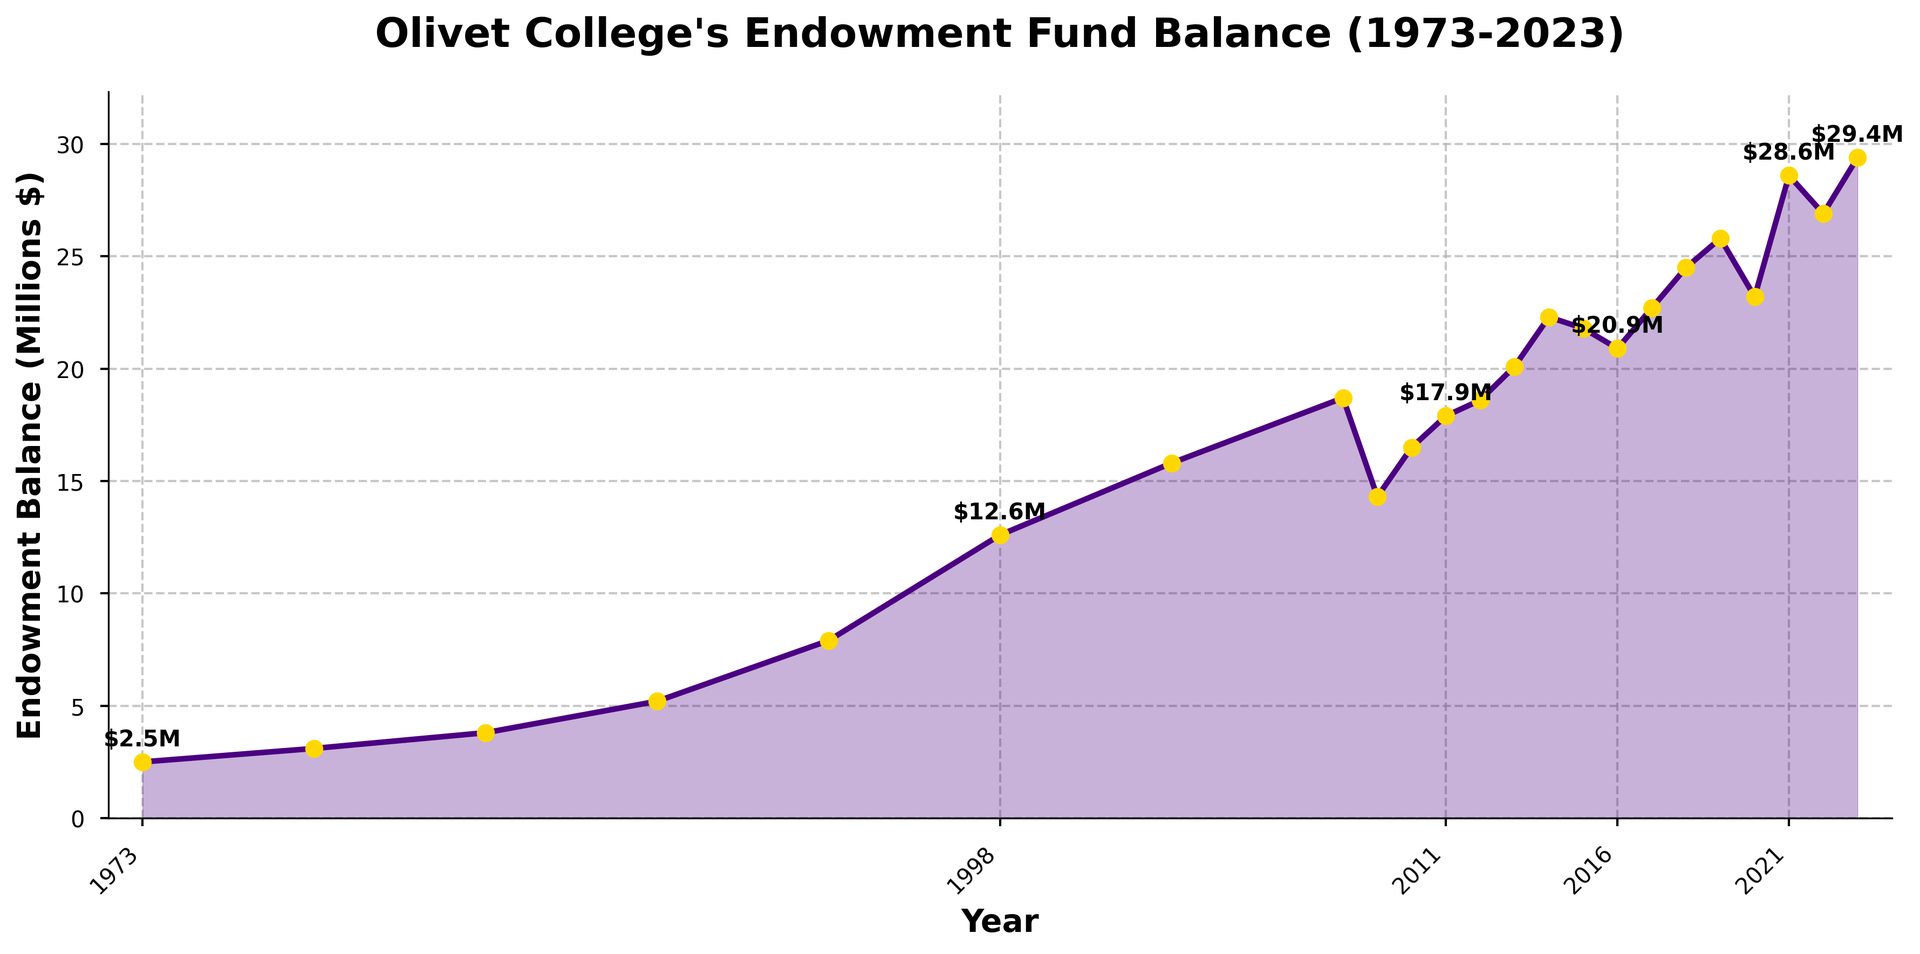What year saw the largest drop in the endowment balance? Look for the year-by-year difference in the endowment balance and find the largest negative change. The balance dropped significantly from 2008 to 2009.
Answer: 2009 What was the endowment balance in 1993? Locate the data point for the year 1993 on the x-axis and read the corresponding y-axis value.
Answer: 7.9 million dollars How much did the endowment balance increase from 1973 to 2023? Subtract the endowment balance in 1973 from the endowment balance in 2023. Balance in 2023 is 29.4 million, and in 1973 it was 2.5 million. So, 29.4 - 2.5 = 26.9 million dollars increase.
Answer: 26.9 million dollars Which year had a higher endowment balance, 2003 or 2013? Compare the y-axis values for the years 2003 and 2013. The balance in 2003 is 15.8 million, and in 2013 it is 20.1 million.
Answer: 2013 What is the average endowment balance over the first decade (1973-1983)? Add the endowment balances for 1973, 1978, and 1983, then divide by the number of data points. (2.5 + 3.1 + 3.8) / 3 = 3.13 million dollars
Answer: 3.13 million dollars In which year did the endowment balance first exceed 20 million dollars? Locate the year on the x-axis at which the endowment balance first crosses the 20 million mark on the y-axis.
Answer: 2013 How does the endowment balance in 2010 compare to that in 2015? Compare the y-axis values for the years 2010 and 2015. The balance in 2010 is 16.5 million, and in 2015 it is 21.8 million.
Answer: 2015 is higher What was the trend in the endowment balance from 2008 to 2010? Observe the slope of the line from 2008 to 2010. The balance decreased in 2009 and then increased in 2010.
Answer: Decrease then increase How many years did the endowment balance stay above 20 million dollars consecutively, starting from 2013? Count the number of consecutive years from 2013 where the balance was above 20 million dollars. This sequence continued until 2023 with a dip in 2020.
Answer: 8 years 